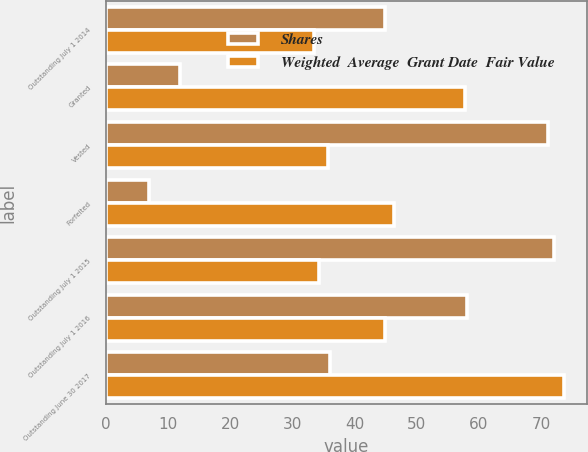Convert chart. <chart><loc_0><loc_0><loc_500><loc_500><stacked_bar_chart><ecel><fcel>Outstanding July 1 2014<fcel>Granted<fcel>Vested<fcel>Forfeited<fcel>Outstanding July 1 2015<fcel>Outstanding July 1 2016<fcel>Outstanding June 30 2017<nl><fcel>Shares<fcel>44.95<fcel>12<fcel>71<fcel>7<fcel>72<fcel>58<fcel>36<nl><fcel>Weighted  Average  Grant Date  Fair Value<fcel>33.56<fcel>57.77<fcel>35.69<fcel>46.39<fcel>34.28<fcel>44.95<fcel>73.66<nl></chart> 